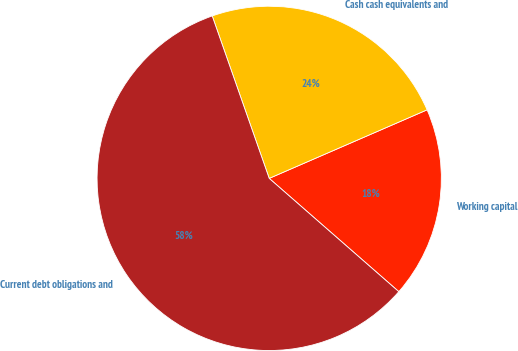Convert chart to OTSL. <chart><loc_0><loc_0><loc_500><loc_500><pie_chart><fcel>Working capital<fcel>Cash cash equivalents and<fcel>Current debt obligations and<nl><fcel>17.95%<fcel>23.85%<fcel>58.19%<nl></chart> 